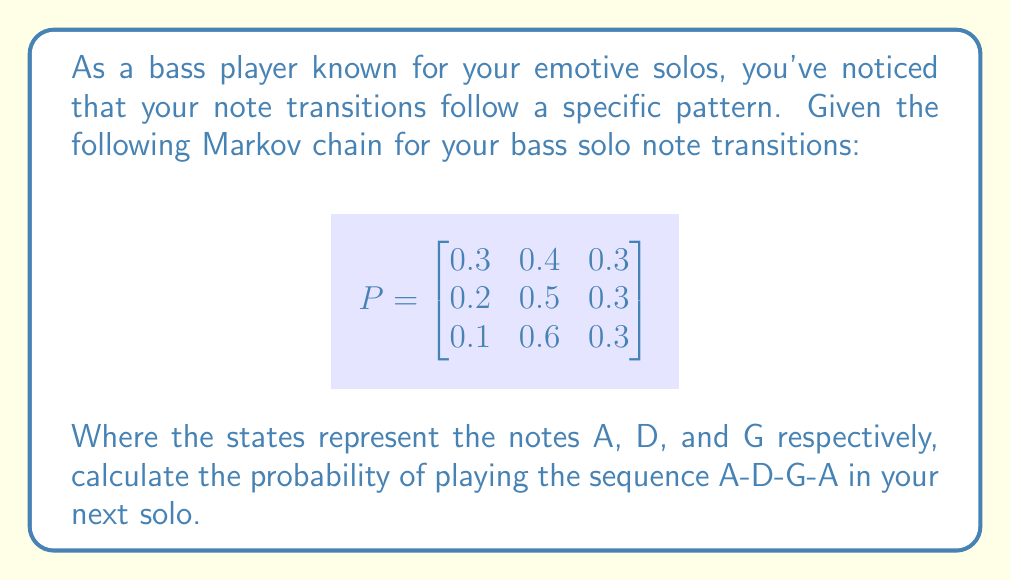Solve this math problem. To solve this problem, we'll use the Markov chain transition matrix and multiply the probabilities for each transition in the sequence A-D-G-A.

Step 1: Identify the transitions
A to D: $P_{12} = 0.4$
D to G: $P_{23} = 0.3$
G to A: $P_{31} = 0.1$

Step 2: Multiply the probabilities
The probability of the sequence A-D-G-A is the product of these individual transition probabilities:

$$P(\text{A-D-G-A}) = P_{12} \times P_{23} \times P_{31}$$

Step 3: Calculate the result
$$P(\text{A-D-G-A}) = 0.4 \times 0.3 \times 0.1 = 0.012$$

Therefore, the probability of playing the sequence A-D-G-A in your next solo is 0.012 or 1.2%.
Answer: 0.012 